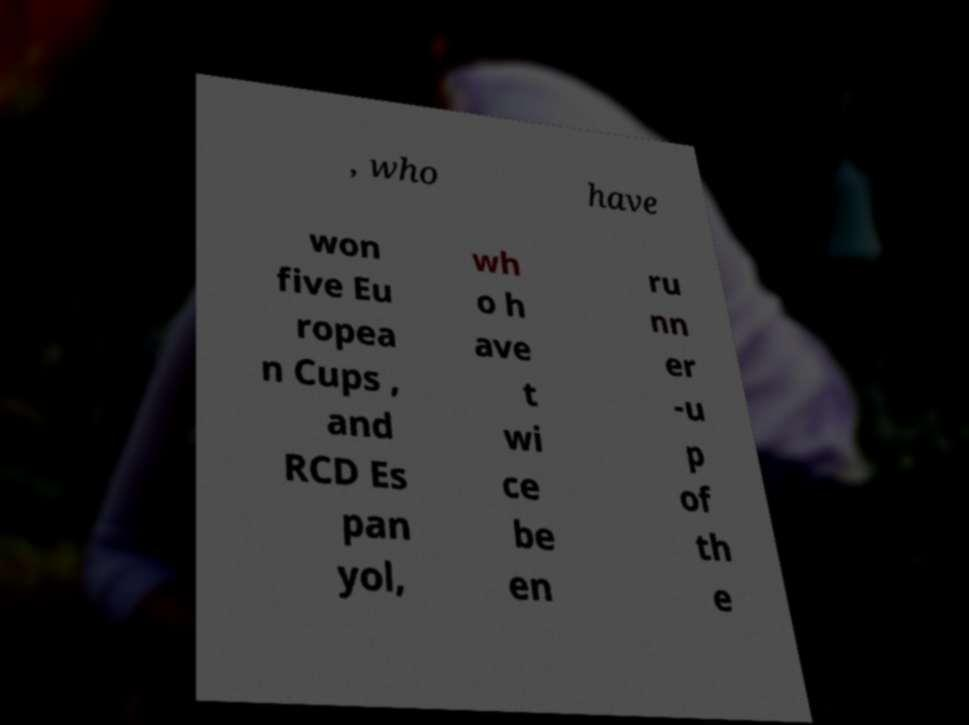Could you extract and type out the text from this image? , who have won five Eu ropea n Cups , and RCD Es pan yol, wh o h ave t wi ce be en ru nn er -u p of th e 